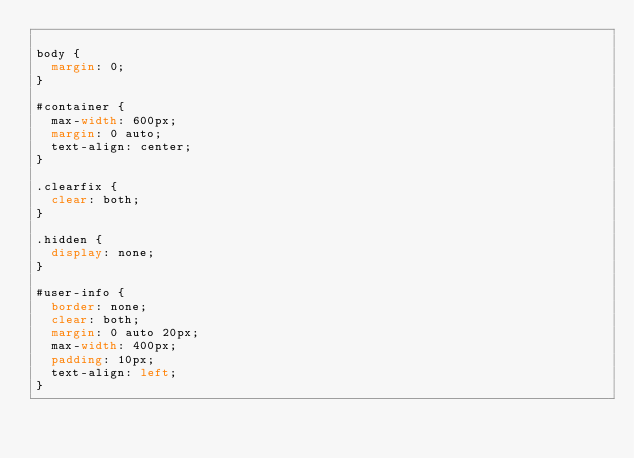Convert code to text. <code><loc_0><loc_0><loc_500><loc_500><_CSS_>
body {
  margin: 0;
}

#container {
  max-width: 600px;
  margin: 0 auto;
  text-align: center;
}

.clearfix {
  clear: both;
}

.hidden {
  display: none;
}

#user-info {
  border: none;
  clear: both;
  margin: 0 auto 20px;
  max-width: 400px;
  padding: 10px;
  text-align: left;
}

</code> 